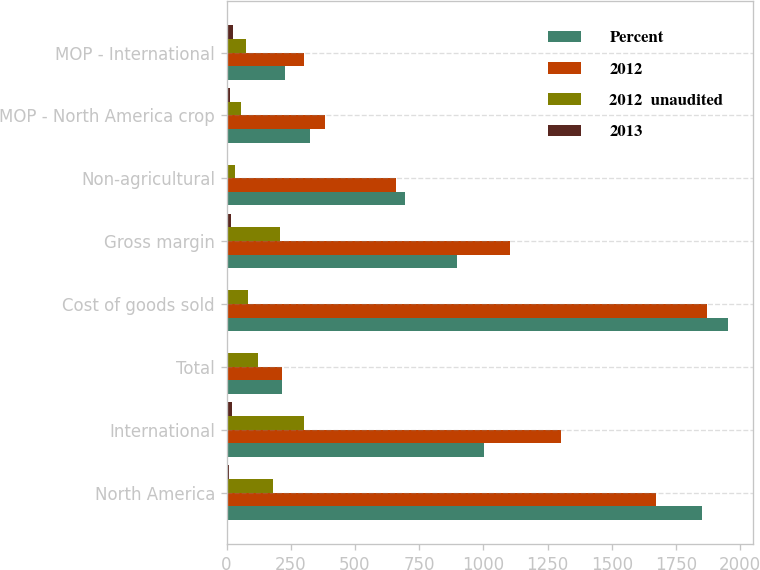<chart> <loc_0><loc_0><loc_500><loc_500><stacked_bar_chart><ecel><fcel>North America<fcel>International<fcel>Total<fcel>Cost of goods sold<fcel>Gross margin<fcel>Non-agricultural<fcel>MOP - North America crop<fcel>MOP - International<nl><fcel>Percent<fcel>1850.2<fcel>1001.4<fcel>216.2<fcel>1953.9<fcel>897.7<fcel>694<fcel>325<fcel>226<nl><fcel>2012<fcel>1670.7<fcel>1302.5<fcel>216.2<fcel>1869.1<fcel>1104.1<fcel>660<fcel>382<fcel>303<nl><fcel>2012  unaudited<fcel>179.5<fcel>301.1<fcel>121.6<fcel>84.8<fcel>206.4<fcel>34<fcel>57<fcel>77<nl><fcel>2013<fcel>10.7<fcel>23.1<fcel>4.1<fcel>4.5<fcel>18.7<fcel>5.2<fcel>14.9<fcel>25.4<nl></chart> 